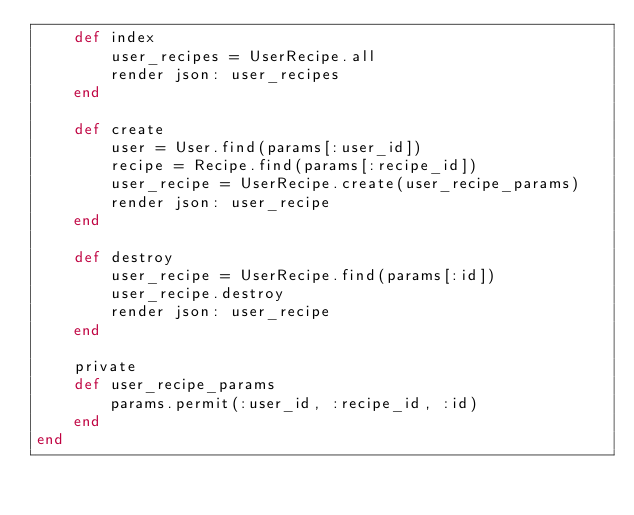<code> <loc_0><loc_0><loc_500><loc_500><_Ruby_>    def index
        user_recipes = UserRecipe.all
        render json: user_recipes      
    end

    def create
        user = User.find(params[:user_id])
        recipe = Recipe.find(params[:recipe_id])
        user_recipe = UserRecipe.create(user_recipe_params)
        render json: user_recipe
    end

    def destroy
        user_recipe = UserRecipe.find(params[:id])
        user_recipe.destroy
        render json: user_recipe 
    end

    private
    def user_recipe_params
        params.permit(:user_id, :recipe_id, :id)
    end
end
</code> 